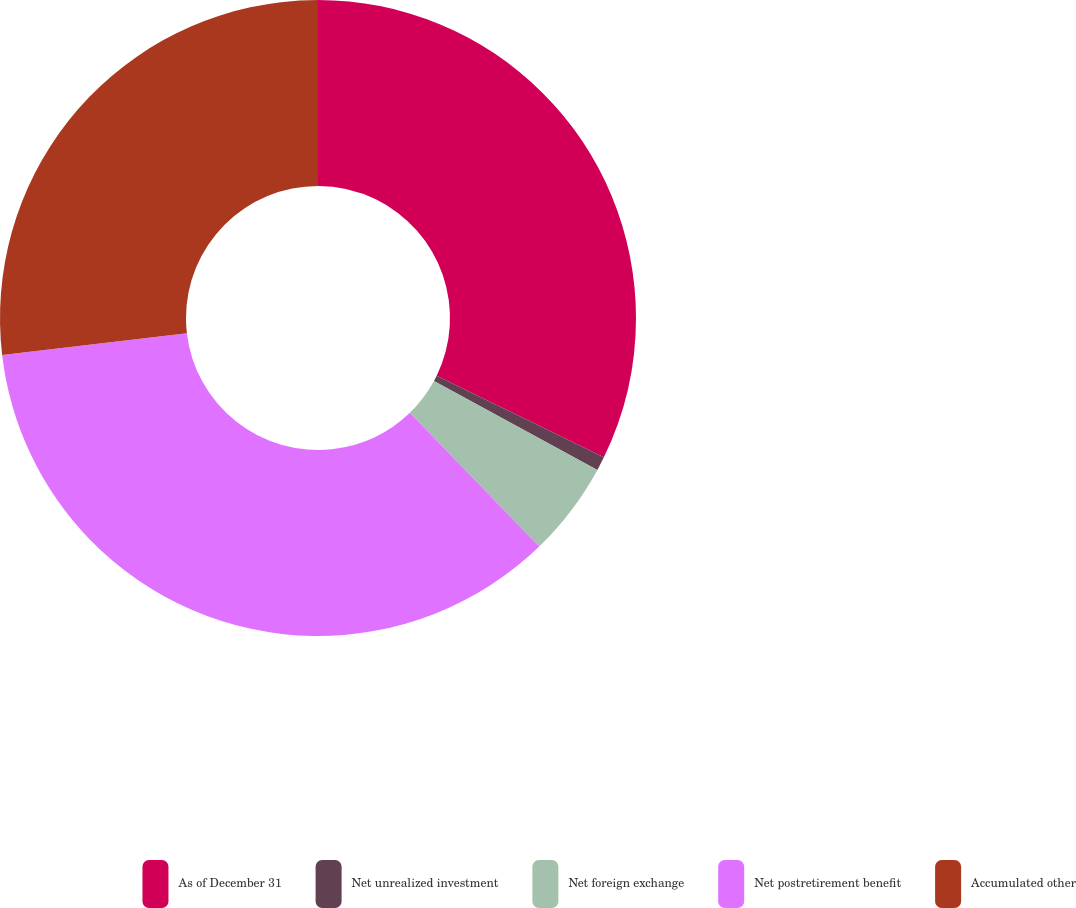Convert chart. <chart><loc_0><loc_0><loc_500><loc_500><pie_chart><fcel>As of December 31<fcel>Net unrealized investment<fcel>Net foreign exchange<fcel>Net postretirement benefit<fcel>Accumulated other<nl><fcel>32.22%<fcel>0.71%<fcel>4.83%<fcel>35.39%<fcel>26.86%<nl></chart> 